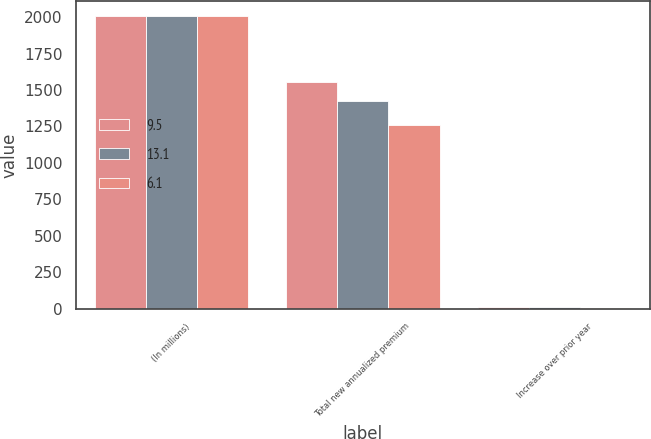<chart> <loc_0><loc_0><loc_500><loc_500><stacked_bar_chart><ecel><fcel>(In millions)<fcel>Total new annualized premium<fcel>Increase over prior year<nl><fcel>9.5<fcel>2007<fcel>1558<fcel>9.5<nl><fcel>13.1<fcel>2006<fcel>1423<fcel>13.1<nl><fcel>6.1<fcel>2005<fcel>1259<fcel>6.1<nl></chart> 